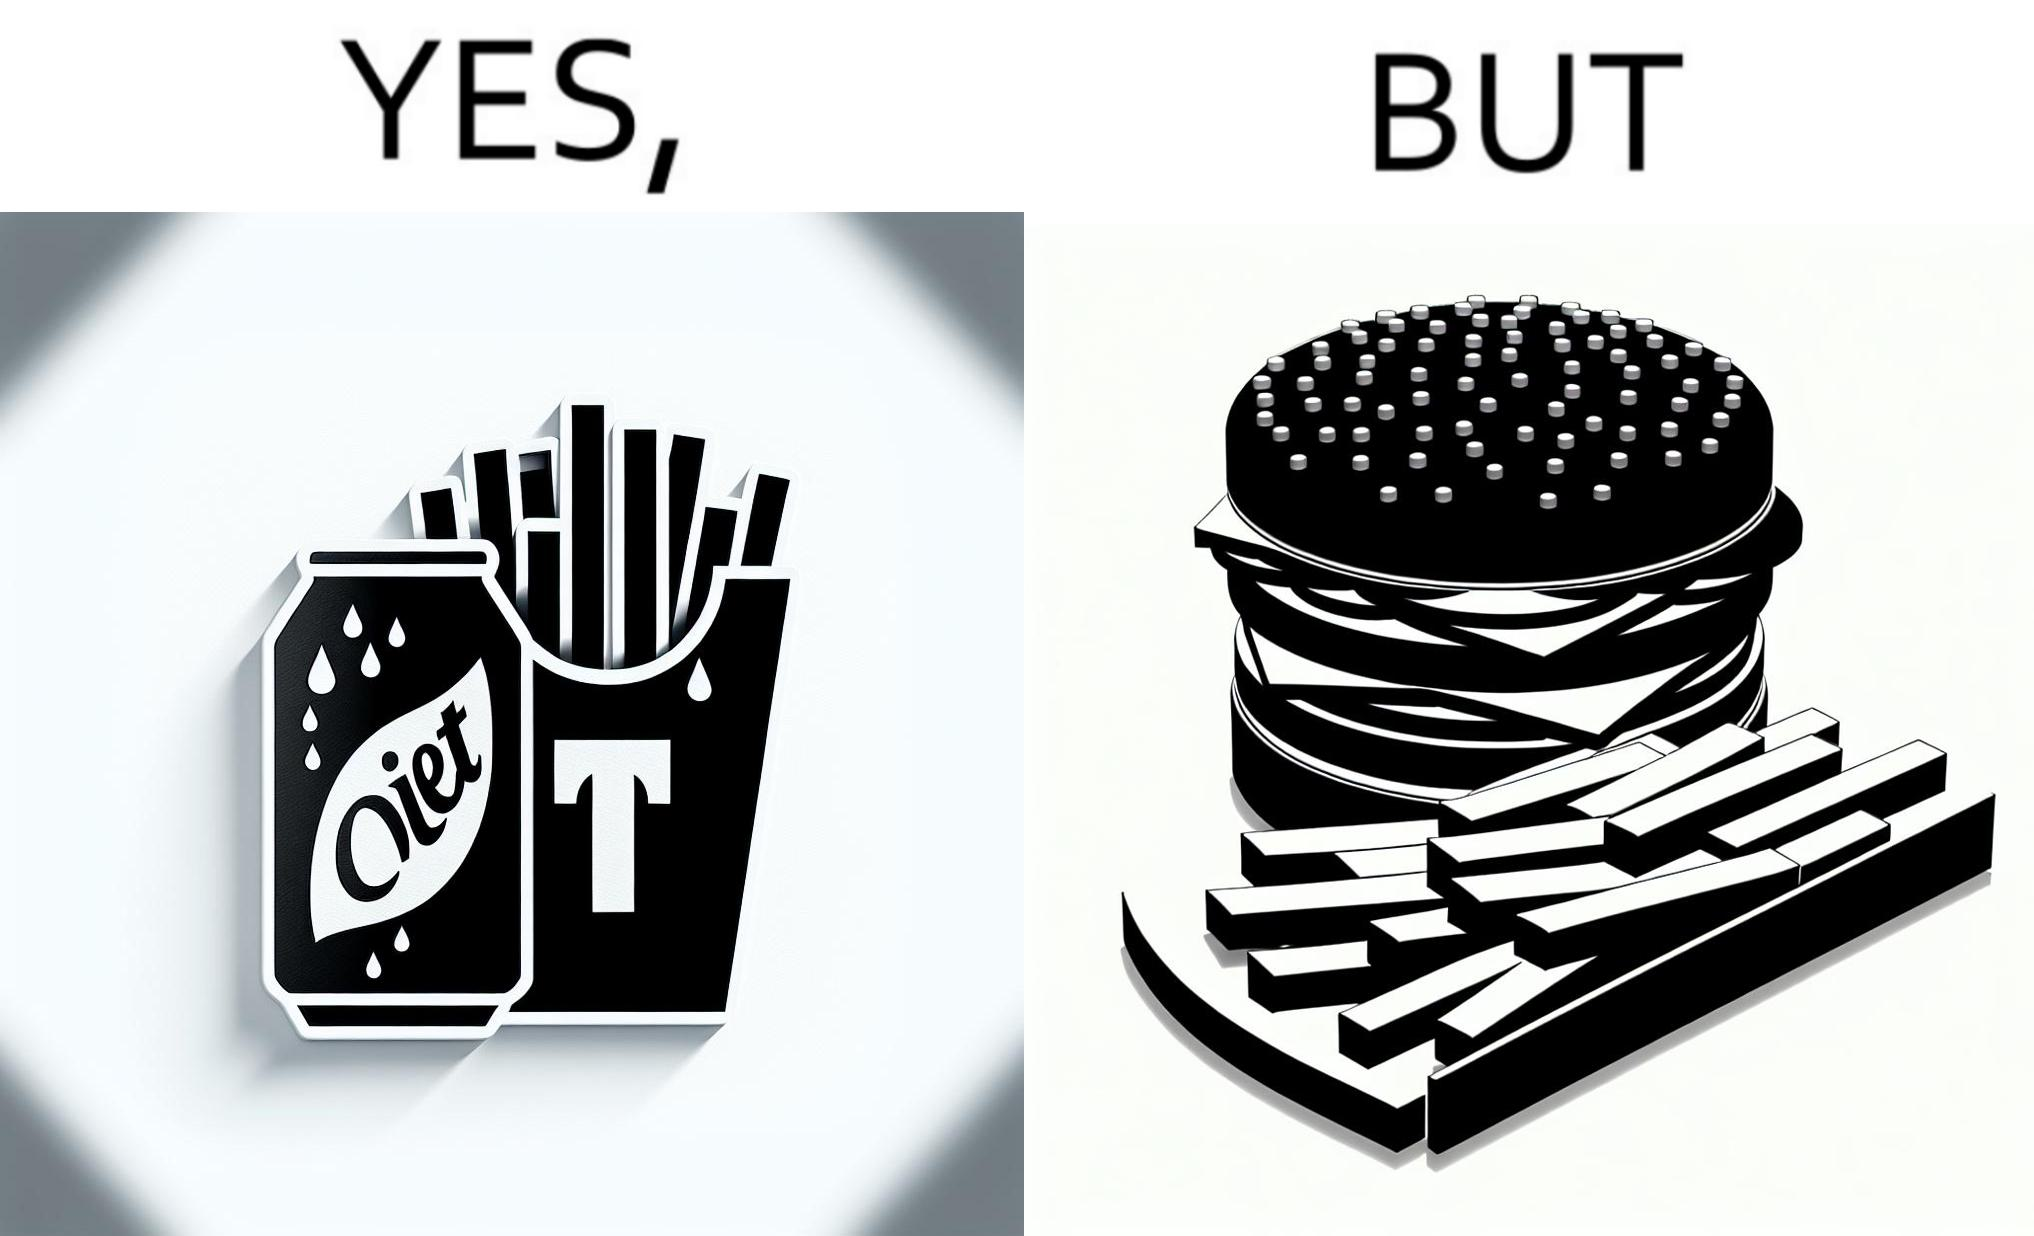What is shown in the left half versus the right half of this image? In the left part of the image: a cold drink can, named by diet cola, with french fries at the back In the right part of the image: a huge size burger with french fries 